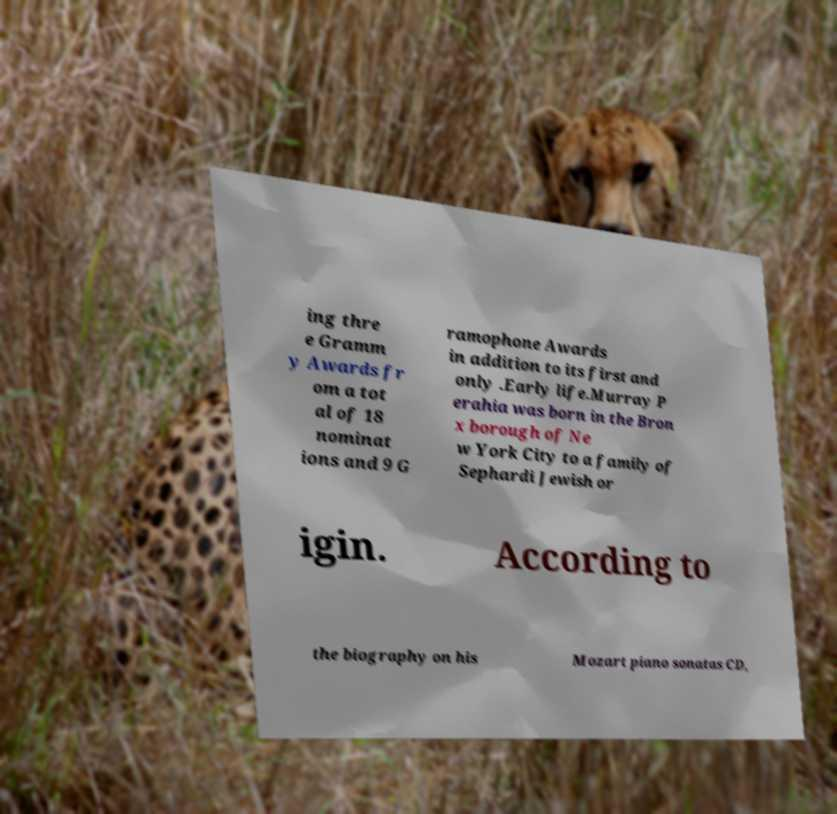There's text embedded in this image that I need extracted. Can you transcribe it verbatim? ing thre e Gramm y Awards fr om a tot al of 18 nominat ions and 9 G ramophone Awards in addition to its first and only .Early life.Murray P erahia was born in the Bron x borough of Ne w York City to a family of Sephardi Jewish or igin. According to the biography on his Mozart piano sonatas CD, 